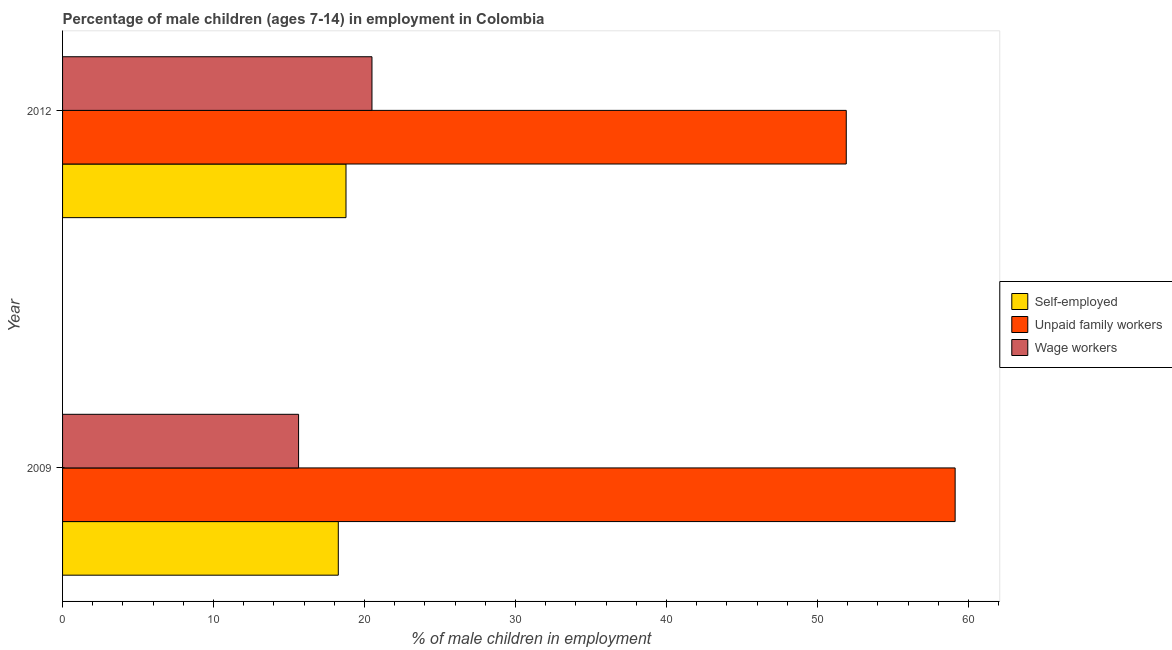How many groups of bars are there?
Provide a succinct answer. 2. Are the number of bars per tick equal to the number of legend labels?
Offer a terse response. Yes. Are the number of bars on each tick of the Y-axis equal?
Offer a terse response. Yes. How many bars are there on the 1st tick from the top?
Offer a terse response. 3. In how many cases, is the number of bars for a given year not equal to the number of legend labels?
Make the answer very short. 0. What is the percentage of children employed as wage workers in 2009?
Your answer should be compact. 15.63. Across all years, what is the maximum percentage of children employed as wage workers?
Your answer should be compact. 20.49. Across all years, what is the minimum percentage of children employed as wage workers?
Offer a terse response. 15.63. In which year was the percentage of self employed children maximum?
Ensure brevity in your answer.  2012. What is the total percentage of children employed as unpaid family workers in the graph?
Ensure brevity in your answer.  111.01. What is the difference between the percentage of children employed as unpaid family workers in 2009 and that in 2012?
Your response must be concise. 7.21. What is the difference between the percentage of children employed as wage workers in 2009 and the percentage of self employed children in 2012?
Make the answer very short. -3.14. What is the average percentage of children employed as unpaid family workers per year?
Provide a short and direct response. 55.51. In the year 2012, what is the difference between the percentage of self employed children and percentage of children employed as wage workers?
Keep it short and to the point. -1.72. In how many years, is the percentage of children employed as wage workers greater than 30 %?
Ensure brevity in your answer.  0. What is the ratio of the percentage of children employed as unpaid family workers in 2009 to that in 2012?
Your response must be concise. 1.14. Is the percentage of children employed as unpaid family workers in 2009 less than that in 2012?
Offer a terse response. No. Is the difference between the percentage of children employed as wage workers in 2009 and 2012 greater than the difference between the percentage of self employed children in 2009 and 2012?
Keep it short and to the point. No. What does the 3rd bar from the top in 2009 represents?
Offer a terse response. Self-employed. What does the 2nd bar from the bottom in 2012 represents?
Offer a very short reply. Unpaid family workers. How many bars are there?
Ensure brevity in your answer.  6. Are all the bars in the graph horizontal?
Your answer should be compact. Yes. Where does the legend appear in the graph?
Keep it short and to the point. Center right. How are the legend labels stacked?
Offer a very short reply. Vertical. What is the title of the graph?
Your response must be concise. Percentage of male children (ages 7-14) in employment in Colombia. What is the label or title of the X-axis?
Keep it short and to the point. % of male children in employment. What is the label or title of the Y-axis?
Offer a terse response. Year. What is the % of male children in employment in Self-employed in 2009?
Give a very brief answer. 18.26. What is the % of male children in employment of Unpaid family workers in 2009?
Provide a short and direct response. 59.11. What is the % of male children in employment in Wage workers in 2009?
Provide a succinct answer. 15.63. What is the % of male children in employment of Self-employed in 2012?
Your answer should be very brief. 18.77. What is the % of male children in employment of Unpaid family workers in 2012?
Give a very brief answer. 51.9. What is the % of male children in employment in Wage workers in 2012?
Your response must be concise. 20.49. Across all years, what is the maximum % of male children in employment in Self-employed?
Make the answer very short. 18.77. Across all years, what is the maximum % of male children in employment in Unpaid family workers?
Provide a succinct answer. 59.11. Across all years, what is the maximum % of male children in employment of Wage workers?
Your answer should be very brief. 20.49. Across all years, what is the minimum % of male children in employment of Self-employed?
Make the answer very short. 18.26. Across all years, what is the minimum % of male children in employment in Unpaid family workers?
Keep it short and to the point. 51.9. Across all years, what is the minimum % of male children in employment in Wage workers?
Ensure brevity in your answer.  15.63. What is the total % of male children in employment in Self-employed in the graph?
Offer a very short reply. 37.03. What is the total % of male children in employment of Unpaid family workers in the graph?
Provide a short and direct response. 111.01. What is the total % of male children in employment of Wage workers in the graph?
Ensure brevity in your answer.  36.12. What is the difference between the % of male children in employment in Self-employed in 2009 and that in 2012?
Your response must be concise. -0.51. What is the difference between the % of male children in employment of Unpaid family workers in 2009 and that in 2012?
Provide a short and direct response. 7.21. What is the difference between the % of male children in employment of Wage workers in 2009 and that in 2012?
Provide a short and direct response. -4.86. What is the difference between the % of male children in employment of Self-employed in 2009 and the % of male children in employment of Unpaid family workers in 2012?
Your answer should be very brief. -33.64. What is the difference between the % of male children in employment in Self-employed in 2009 and the % of male children in employment in Wage workers in 2012?
Provide a succinct answer. -2.23. What is the difference between the % of male children in employment in Unpaid family workers in 2009 and the % of male children in employment in Wage workers in 2012?
Offer a terse response. 38.62. What is the average % of male children in employment of Self-employed per year?
Ensure brevity in your answer.  18.52. What is the average % of male children in employment in Unpaid family workers per year?
Ensure brevity in your answer.  55.51. What is the average % of male children in employment in Wage workers per year?
Make the answer very short. 18.06. In the year 2009, what is the difference between the % of male children in employment of Self-employed and % of male children in employment of Unpaid family workers?
Your answer should be very brief. -40.85. In the year 2009, what is the difference between the % of male children in employment of Self-employed and % of male children in employment of Wage workers?
Offer a terse response. 2.63. In the year 2009, what is the difference between the % of male children in employment in Unpaid family workers and % of male children in employment in Wage workers?
Keep it short and to the point. 43.48. In the year 2012, what is the difference between the % of male children in employment of Self-employed and % of male children in employment of Unpaid family workers?
Provide a short and direct response. -33.13. In the year 2012, what is the difference between the % of male children in employment in Self-employed and % of male children in employment in Wage workers?
Your answer should be very brief. -1.72. In the year 2012, what is the difference between the % of male children in employment in Unpaid family workers and % of male children in employment in Wage workers?
Your answer should be very brief. 31.41. What is the ratio of the % of male children in employment of Self-employed in 2009 to that in 2012?
Your answer should be compact. 0.97. What is the ratio of the % of male children in employment of Unpaid family workers in 2009 to that in 2012?
Make the answer very short. 1.14. What is the ratio of the % of male children in employment of Wage workers in 2009 to that in 2012?
Provide a short and direct response. 0.76. What is the difference between the highest and the second highest % of male children in employment of Self-employed?
Offer a very short reply. 0.51. What is the difference between the highest and the second highest % of male children in employment in Unpaid family workers?
Your answer should be compact. 7.21. What is the difference between the highest and the second highest % of male children in employment in Wage workers?
Provide a succinct answer. 4.86. What is the difference between the highest and the lowest % of male children in employment of Self-employed?
Provide a short and direct response. 0.51. What is the difference between the highest and the lowest % of male children in employment of Unpaid family workers?
Provide a short and direct response. 7.21. What is the difference between the highest and the lowest % of male children in employment in Wage workers?
Make the answer very short. 4.86. 